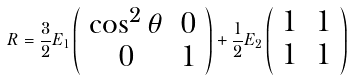Convert formula to latex. <formula><loc_0><loc_0><loc_500><loc_500>R = \frac { 3 } { 2 } E _ { 1 } \left ( \begin{array} { c c } \cos ^ { 2 } \theta & 0 \\ 0 & 1 \end{array} \right ) + \frac { 1 } { 2 } E _ { 2 } \left ( \begin{array} { c c } 1 & 1 \\ 1 & 1 \end{array} \right )</formula> 